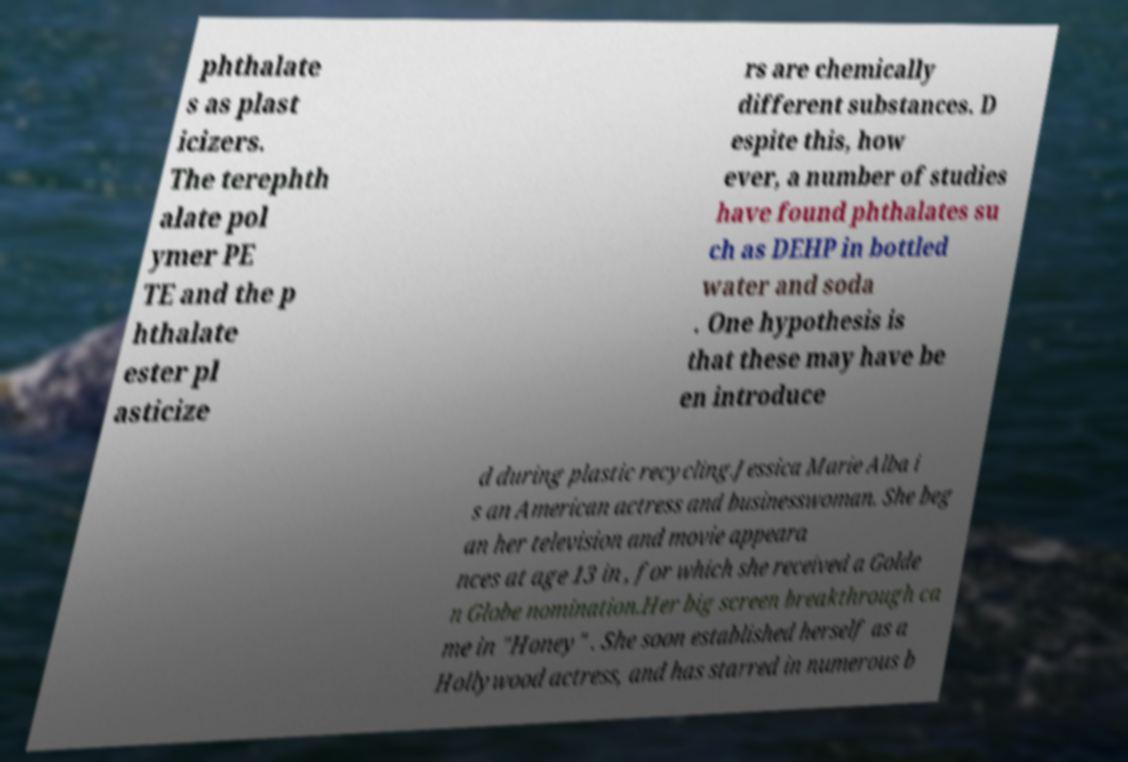Please read and relay the text visible in this image. What does it say? phthalate s as plast icizers. The terephth alate pol ymer PE TE and the p hthalate ester pl asticize rs are chemically different substances. D espite this, how ever, a number of studies have found phthalates su ch as DEHP in bottled water and soda . One hypothesis is that these may have be en introduce d during plastic recycling.Jessica Marie Alba i s an American actress and businesswoman. She beg an her television and movie appeara nces at age 13 in , for which she received a Golde n Globe nomination.Her big screen breakthrough ca me in "Honey" . She soon established herself as a Hollywood actress, and has starred in numerous b 